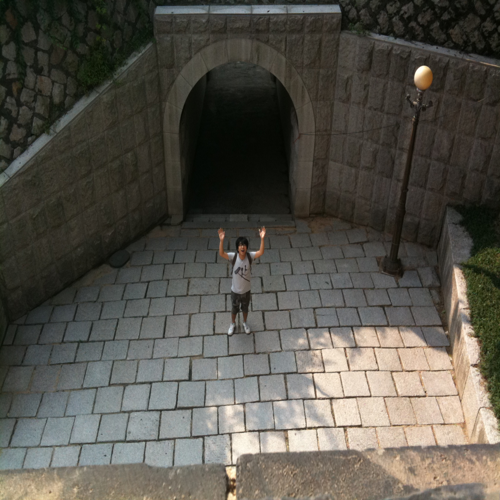The person in the picture seems to be gesturing. What does that tell us about this moment? The person's raised arms and open body language convey a sense of excitement or celebration, suggesting that this moment may hold personal significance or that they are simply enjoying the outdoor experience. 